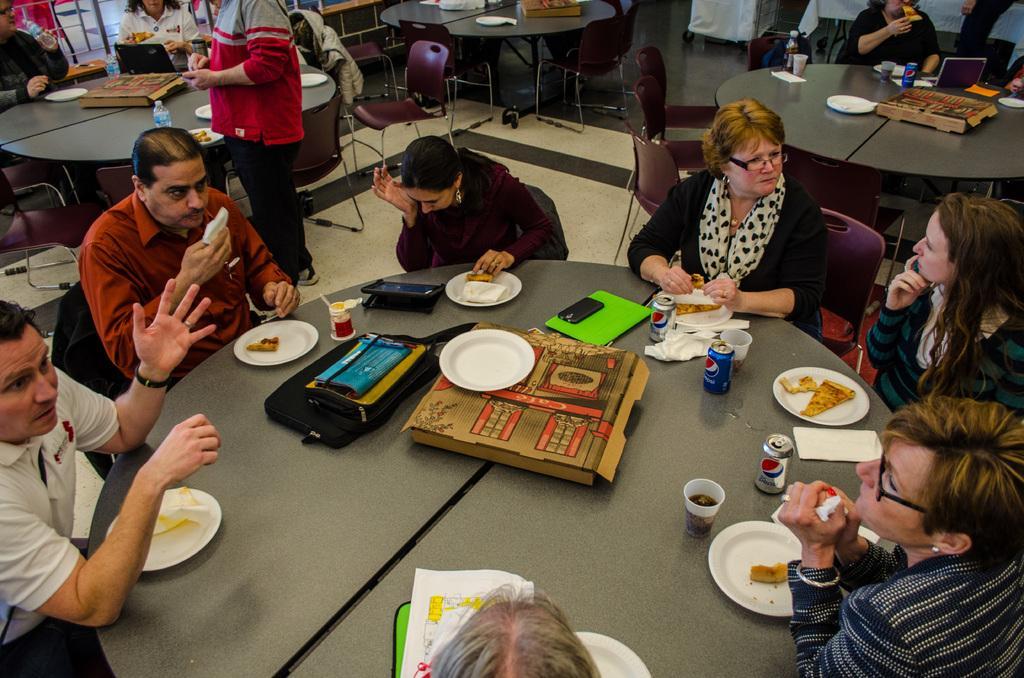How would you summarize this image in a sentence or two? There are group of people sitting on the chairs. This is the table with bags,plates,tablet,book,tins and a cardboard placed on it. At background I can see a person standing,and I can find some empty chairs. 